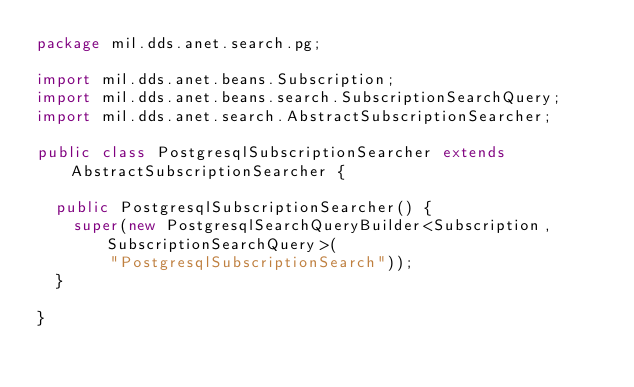<code> <loc_0><loc_0><loc_500><loc_500><_Java_>package mil.dds.anet.search.pg;

import mil.dds.anet.beans.Subscription;
import mil.dds.anet.beans.search.SubscriptionSearchQuery;
import mil.dds.anet.search.AbstractSubscriptionSearcher;

public class PostgresqlSubscriptionSearcher extends AbstractSubscriptionSearcher {

  public PostgresqlSubscriptionSearcher() {
    super(new PostgresqlSearchQueryBuilder<Subscription, SubscriptionSearchQuery>(
        "PostgresqlSubscriptionSearch"));
  }

}
</code> 